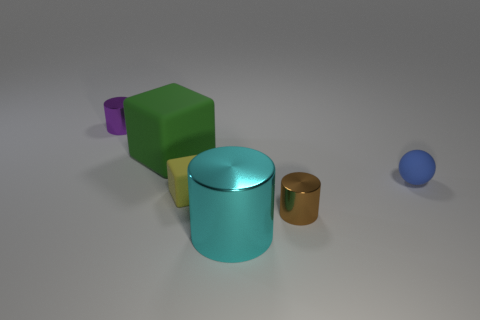There is a object that is in front of the yellow block and to the left of the brown shiny object; what is its color?
Offer a terse response. Cyan. What number of things are either small rubber objects that are on the left side of the big cyan cylinder or large metallic cylinders?
Give a very brief answer. 2. Is the number of tiny metallic objects to the right of the large metal cylinder the same as the number of large yellow metallic cubes?
Ensure brevity in your answer.  No. There is a tiny shiny thing that is to the right of the shiny thing behind the yellow thing; how many green matte objects are on the left side of it?
Your response must be concise. 1. Does the brown metal thing have the same size as the object that is in front of the brown object?
Make the answer very short. No. How many brown cubes are there?
Give a very brief answer. 0. There is a matte object to the right of the tiny brown shiny cylinder; does it have the same size as the rubber cube that is on the left side of the small yellow matte block?
Your answer should be very brief. No. There is another thing that is the same shape as the yellow object; what is its color?
Offer a very short reply. Green. Does the small purple shiny object have the same shape as the cyan metallic object?
Ensure brevity in your answer.  Yes. There is a purple thing that is the same shape as the tiny brown thing; what size is it?
Offer a terse response. Small. 